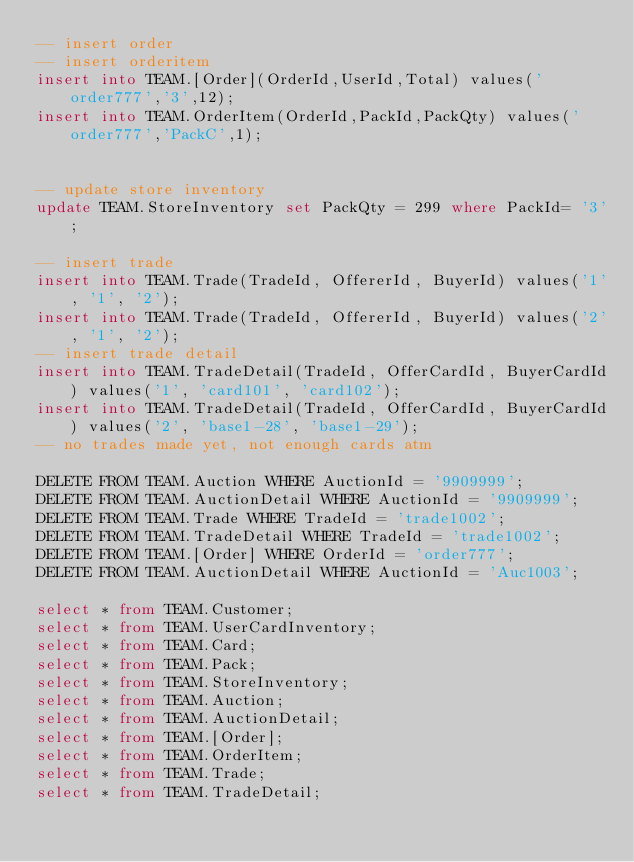<code> <loc_0><loc_0><loc_500><loc_500><_SQL_>-- insert order
-- insert orderitem
insert into TEAM.[Order](OrderId,UserId,Total) values('order777','3',12);
insert into TEAM.OrderItem(OrderId,PackId,PackQty) values('order777','PackC',1);


-- update store inventory
update TEAM.StoreInventory set PackQty = 299 where PackId= '3';

-- insert trade
insert into TEAM.Trade(TradeId, OffererId, BuyerId) values('1', '1', '2');
insert into TEAM.Trade(TradeId, OffererId, BuyerId) values('2', '1', '2');
-- insert trade detail
insert into TEAM.TradeDetail(TradeId, OfferCardId, BuyerCardId) values('1', 'card101', 'card102');
insert into TEAM.TradeDetail(TradeId, OfferCardId, BuyerCardId) values('2', 'base1-28', 'base1-29');
-- no trades made yet, not enough cards atm

DELETE FROM TEAM.Auction WHERE AuctionId = '9909999';
DELETE FROM TEAM.AuctionDetail WHERE AuctionId = '9909999';
DELETE FROM TEAM.Trade WHERE TradeId = 'trade1002';
DELETE FROM TEAM.TradeDetail WHERE TradeId = 'trade1002';
DELETE FROM TEAM.[Order] WHERE OrderId = 'order777';
DELETE FROM TEAM.AuctionDetail WHERE AuctionId = 'Auc1003';

select * from TEAM.Customer;
select * from TEAM.UserCardInventory;
select * from TEAM.Card;
select * from TEAM.Pack;
select * from TEAM.StoreInventory;
select * from TEAM.Auction;
select * from TEAM.AuctionDetail;
select * from TEAM.[Order];
select * from TEAM.OrderItem;
select * from TEAM.Trade;
select * from TEAM.TradeDetail;</code> 